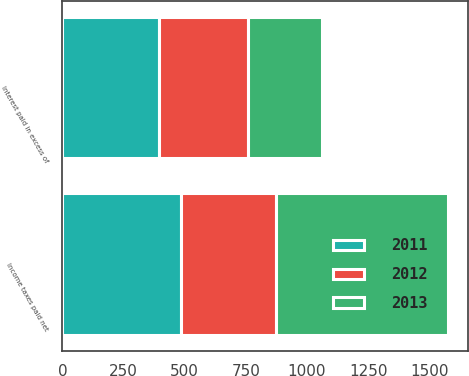Convert chart. <chart><loc_0><loc_0><loc_500><loc_500><stacked_bar_chart><ecel><fcel>Interest paid in excess of<fcel>Income taxes paid net<nl><fcel>2012<fcel>361<fcel>387<nl><fcel>2013<fcel>302<fcel>705<nl><fcel>2011<fcel>397<fcel>486<nl></chart> 